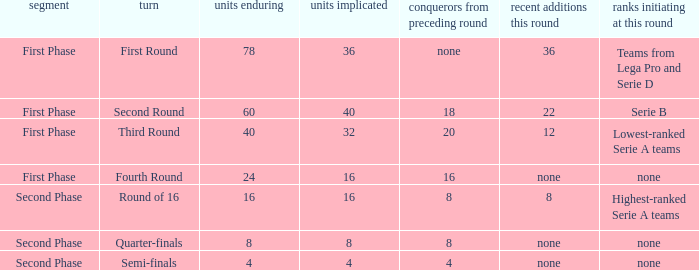Clubs involved is 8, what number would you find from winners from previous round? 8.0. 